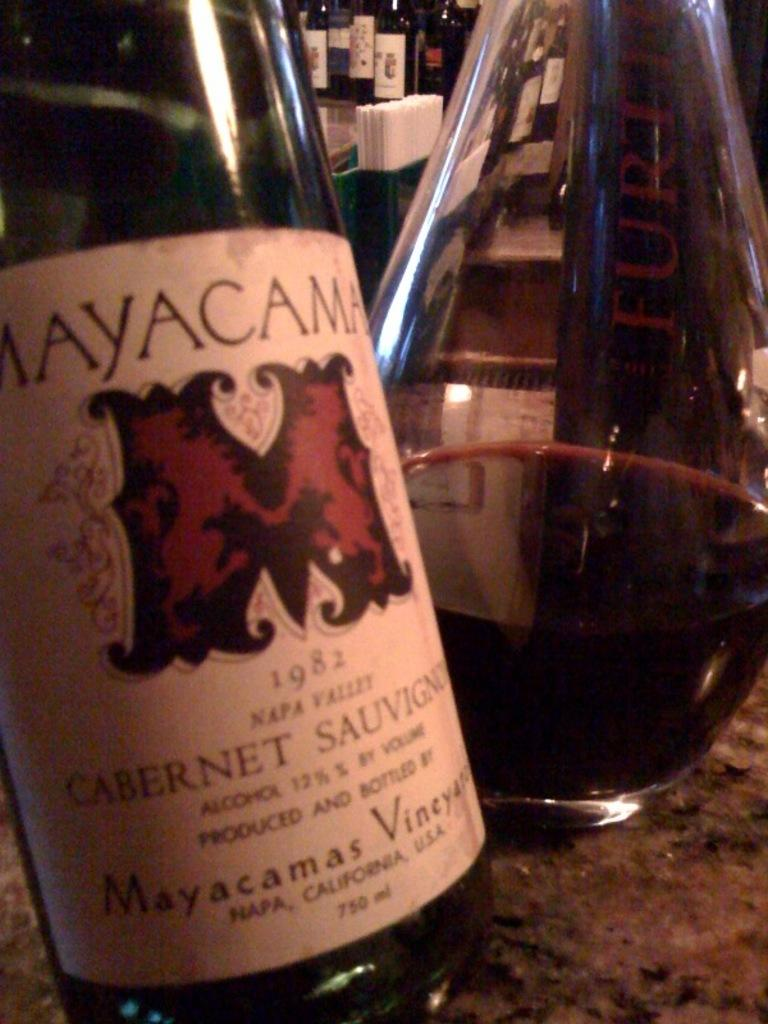<image>
Describe the image concisely. A MayaCama Cabernet Sauvignon wine bottle beside a decanter filled with wine. 